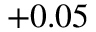<formula> <loc_0><loc_0><loc_500><loc_500>+ 0 . 0 5</formula> 